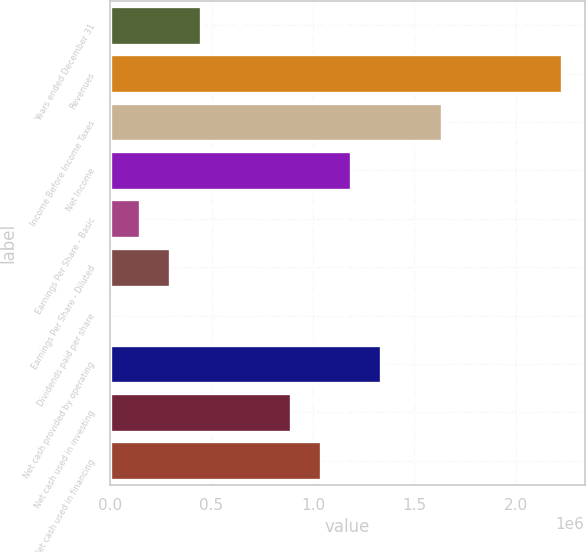Convert chart to OTSL. <chart><loc_0><loc_0><loc_500><loc_500><bar_chart><fcel>Years ended December 31<fcel>Revenues<fcel>Income Before Income Taxes<fcel>Net Income<fcel>Earnings Per Share - Basic<fcel>Earnings Per Share - Diluted<fcel>Dividends paid per share<fcel>Net cash provided by operating<fcel>Net cash used in investing<fcel>Net cash used in financing<nl><fcel>445592<fcel>2.22796e+06<fcel>1.63384e+06<fcel>1.18824e+06<fcel>148531<fcel>297061<fcel>0.42<fcel>1.33677e+06<fcel>891183<fcel>1.03971e+06<nl></chart> 